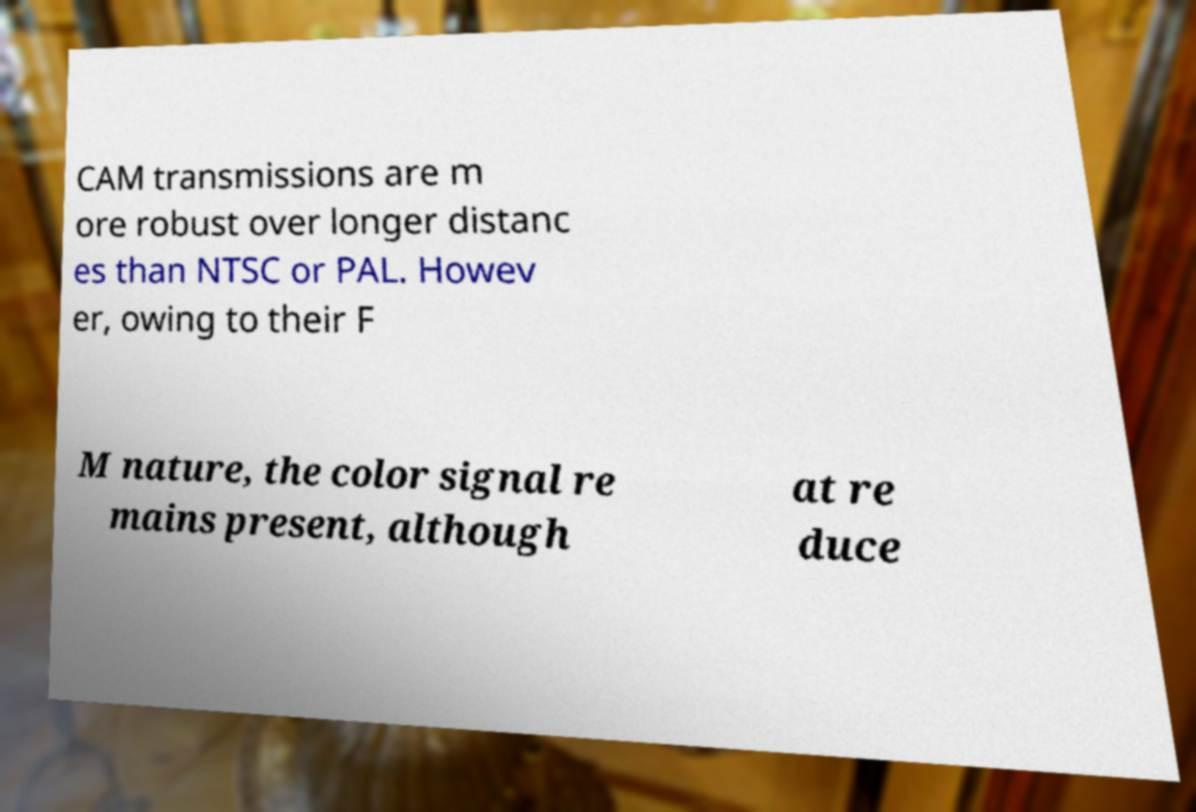For documentation purposes, I need the text within this image transcribed. Could you provide that? CAM transmissions are m ore robust over longer distanc es than NTSC or PAL. Howev er, owing to their F M nature, the color signal re mains present, although at re duce 